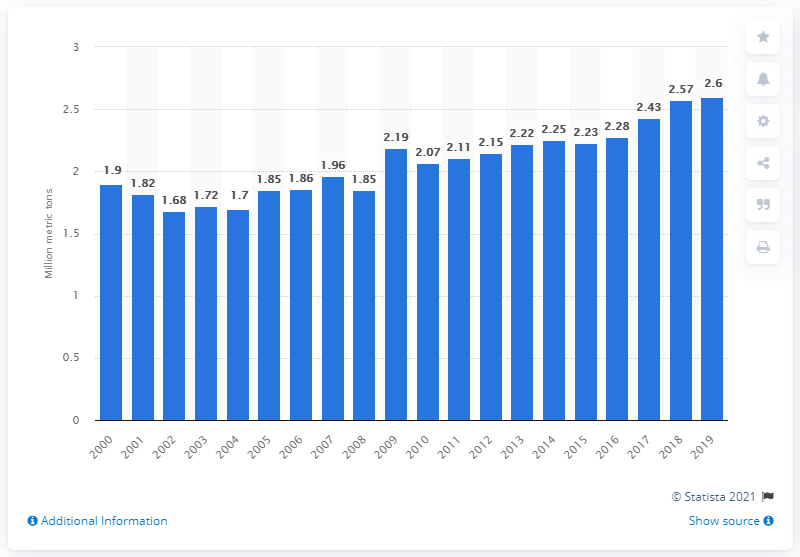Point out several critical features in this image. The global cherry production in 2019 was 2.6 million metric tons. In the previous year, the production of cherries was 2.57... 